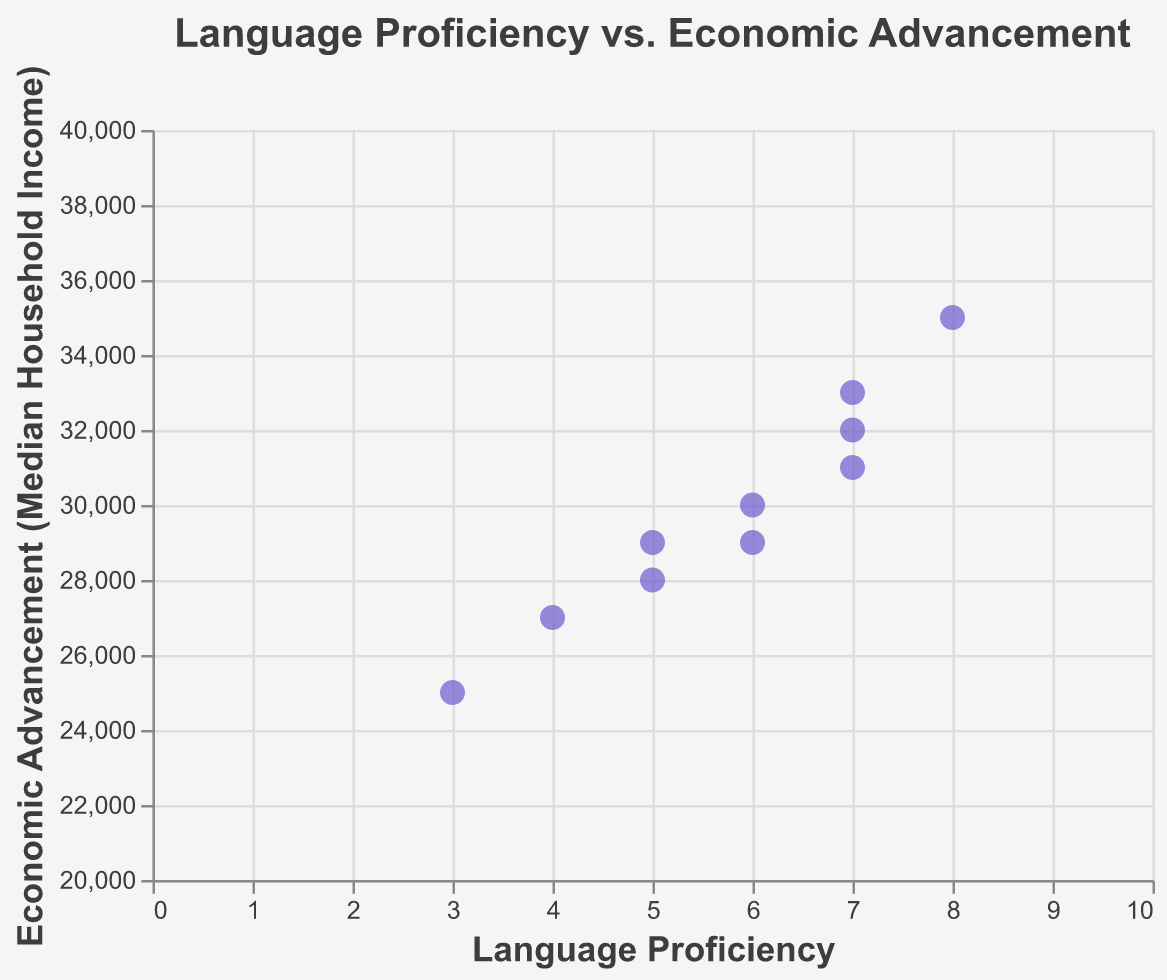What's the title of the scatter plot? The title of the scatter plot is the text displayed prominently at the top of the chart. The title provides an overview of the data being visualized.
Answer: Language Proficiency vs. Economic Advancement How many communities have a language proficiency of 7? Count the number of data points (represented by dots) where the x-axis value (Language Proficiency) is 7.
Answer: 3 Which community has the highest median household income? Identify the data point with the highest y-axis value (Economic Advancement) and read its corresponding tooltip.
Answer: Cherokee Nation What is the range of language proficiency scores displayed in the plot? Look at the minimum and maximum values along the x-axis to determine the range.
Answer: 3 to 8 What is the economic advancement (median household income) for the Lumbee community? Locate the data point for the Lumbee community and visualize its positioning on the y-axis.
Answer: $25,000 Is there a visible trend or correlation between language proficiency and economic advancement? Inspect the general direction of the data points' distribution from left to right. A visible upward or downward trend would indicate a correlation.
Answer: There appears to be a slight positive trend What is the combined median household income for communities with a language proficiency score of 6? Locate the data points where the Language Proficiency is 6 and sum their corresponding y-axis values (Economic Advancement). For the given data, the communities are Ojibwe ($29,000) and Blackfeet ($30,000). 29000 + 30000 = 59000.
Answer: $59,000 Which community has the lowest economic advancement, and what is its language proficiency? Identify the data point with the lowest y-axis value and then read its x-axis value and tooltip.
Answer: Lumbee, 3 How does the economic advancement of Apache compare to that of Choctaw? Find the data points for Apache and Choctaw, and compare their positions along the y-axis.
Answer: Apache has a lower economic advancement ($27,000) compared to Choctaw ($32,000) Do any communities have the same language proficiency score but different economic advancement levels? Look for data points that align vertically (same x-axis values) but have different y-axis values. Communities with Language Proficiency scores of 5 (Sioux and Hopi) have different economic advancements ($28,000 and $29,000, respectively).
Answer: Yes 